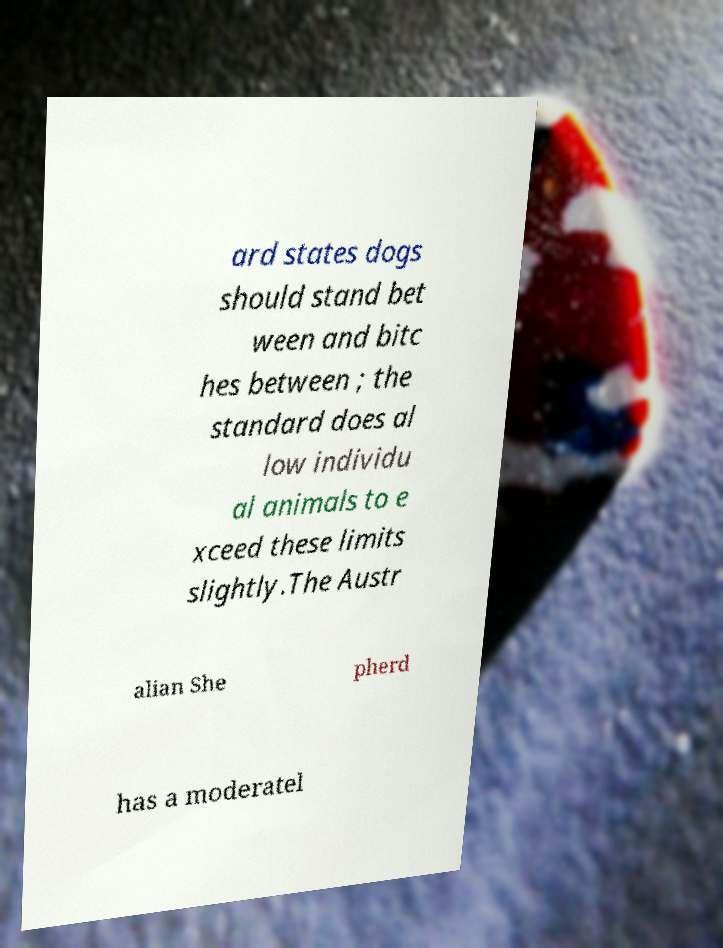I need the written content from this picture converted into text. Can you do that? ard states dogs should stand bet ween and bitc hes between ; the standard does al low individu al animals to e xceed these limits slightly.The Austr alian She pherd has a moderatel 